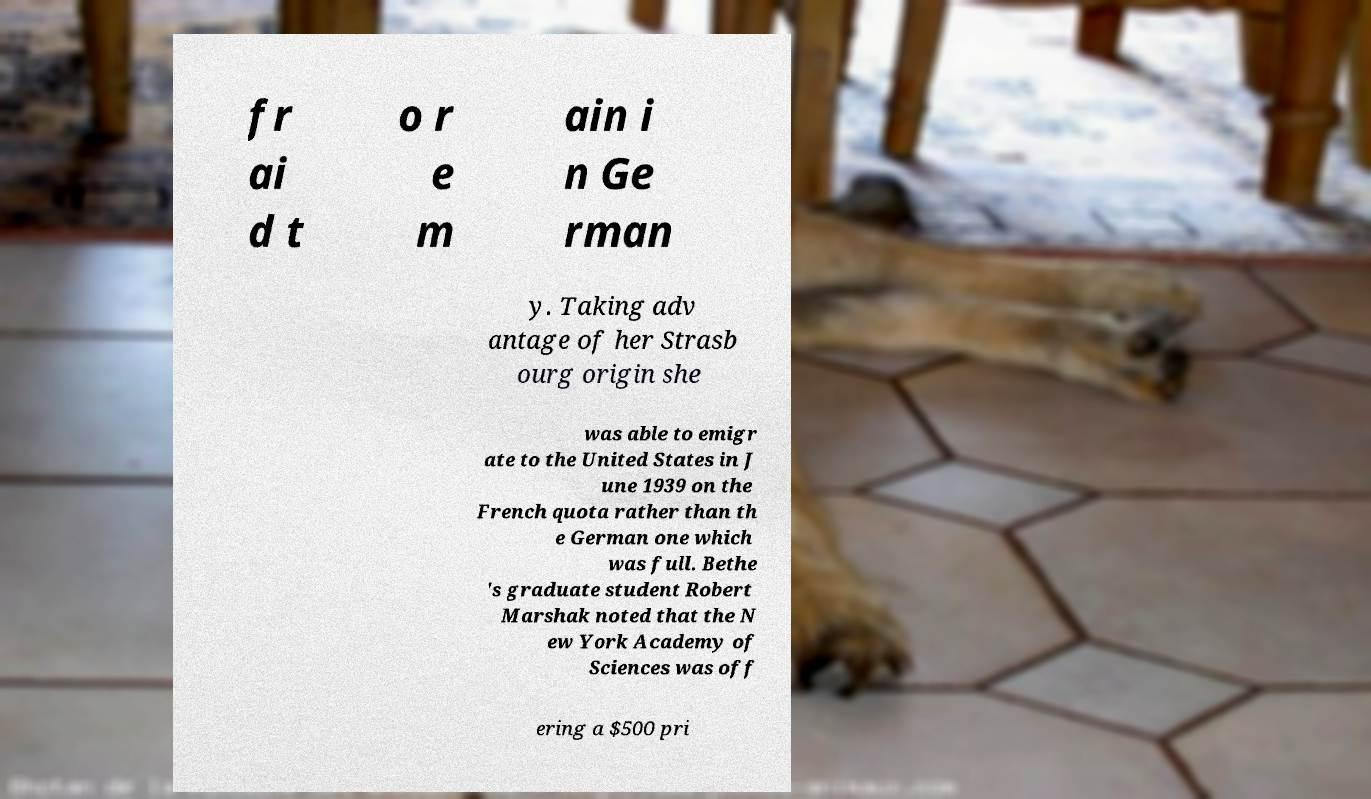Please read and relay the text visible in this image. What does it say? fr ai d t o r e m ain i n Ge rman y. Taking adv antage of her Strasb ourg origin she was able to emigr ate to the United States in J une 1939 on the French quota rather than th e German one which was full. Bethe 's graduate student Robert Marshak noted that the N ew York Academy of Sciences was off ering a $500 pri 